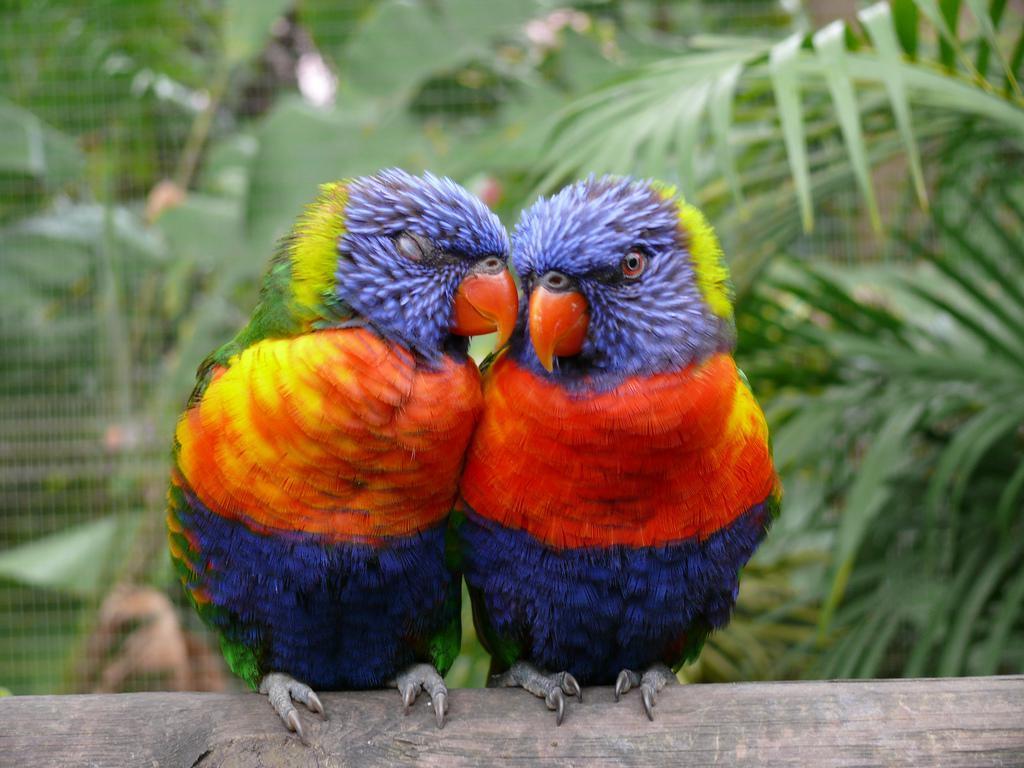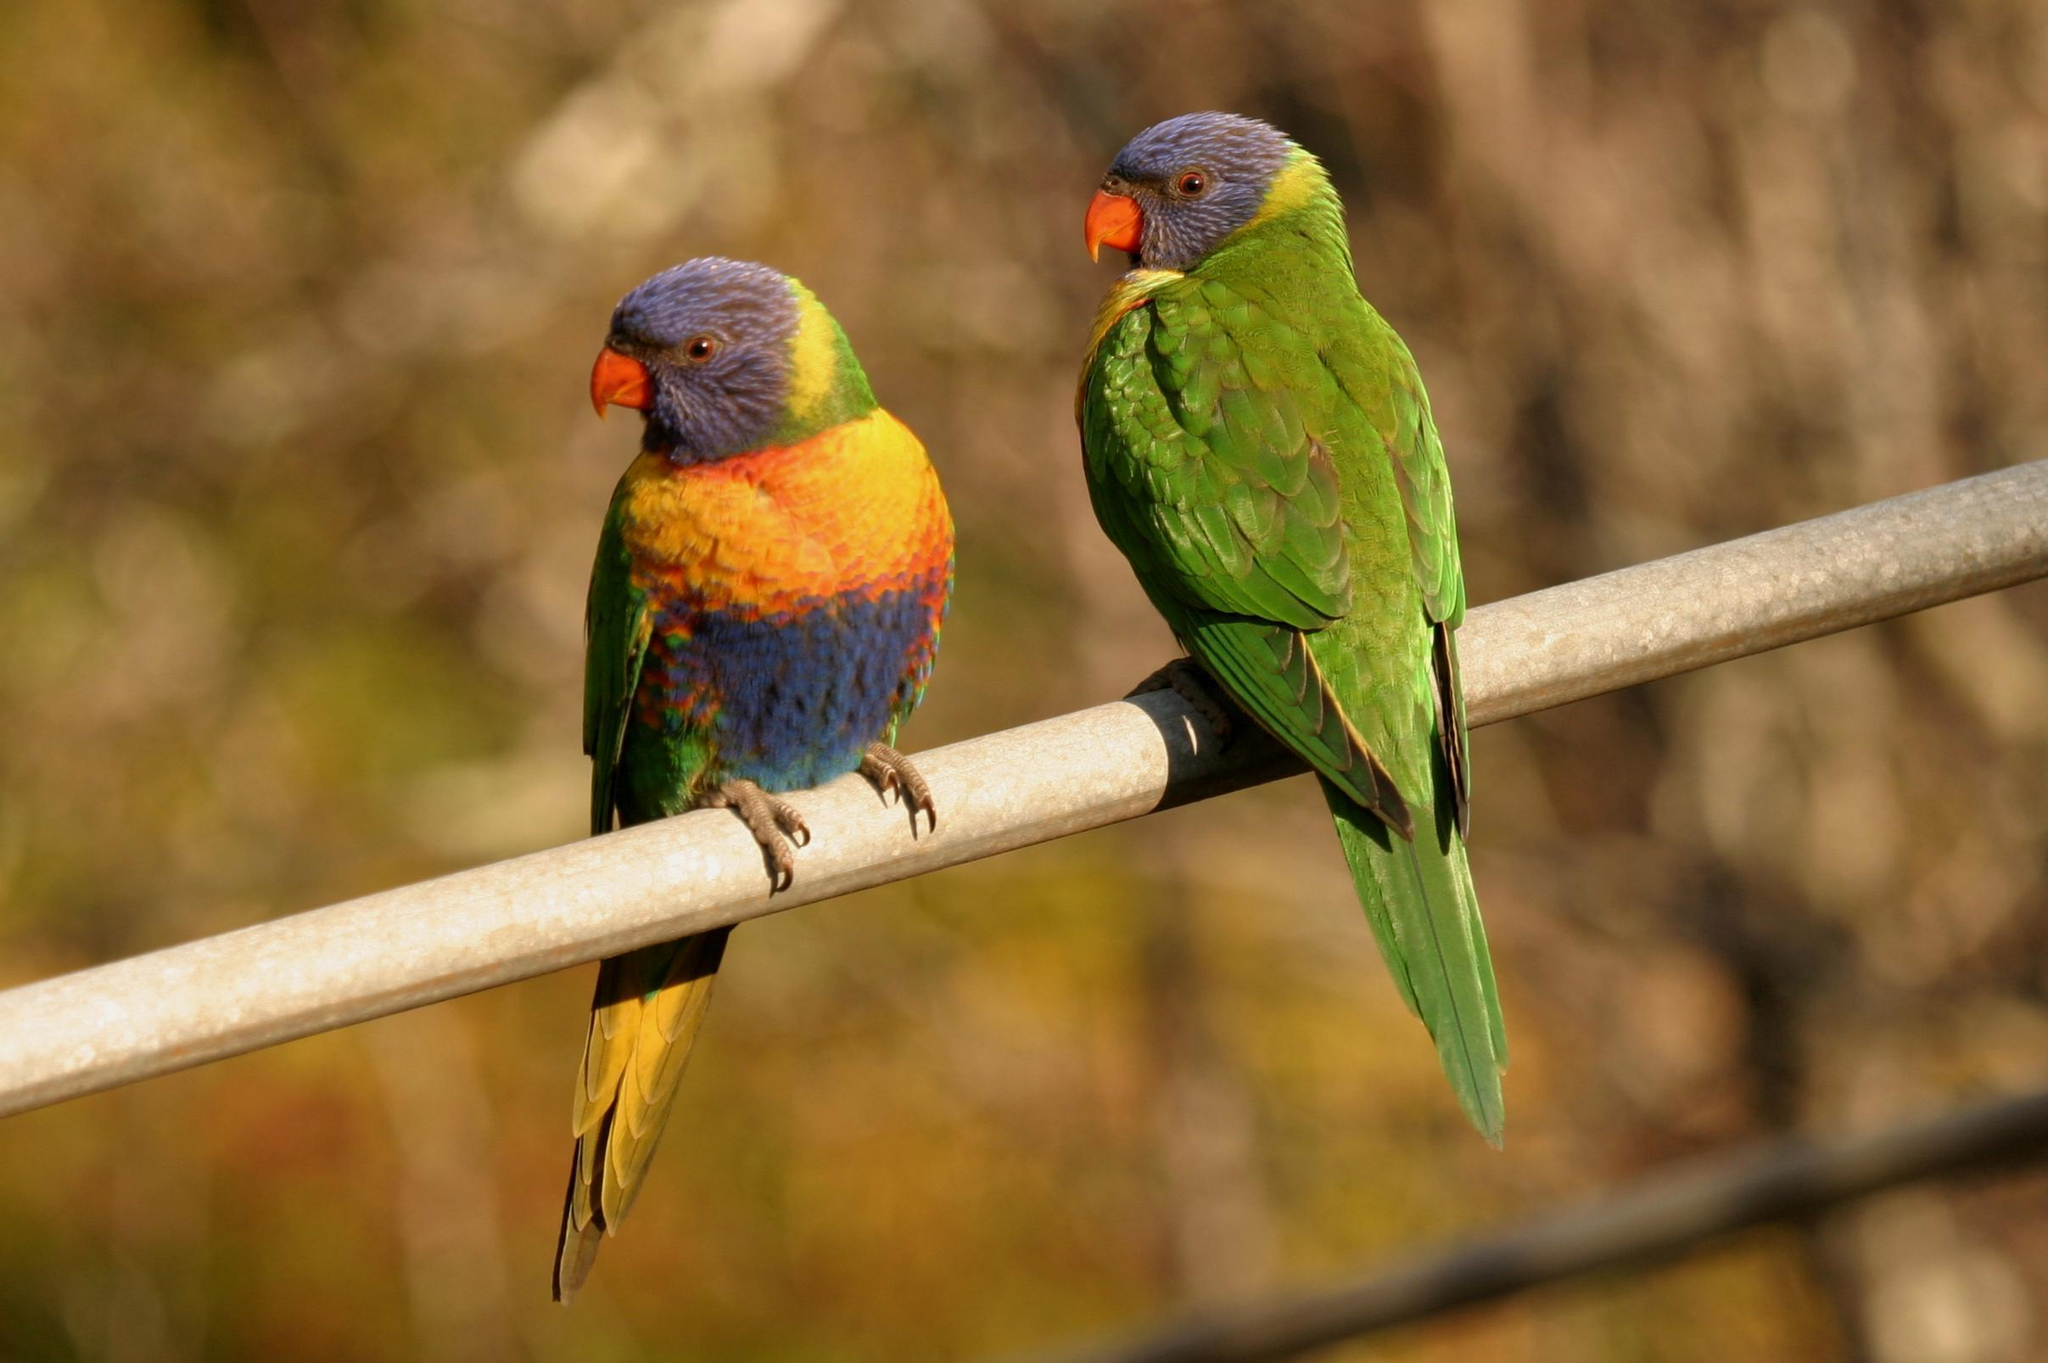The first image is the image on the left, the second image is the image on the right. For the images displayed, is the sentence "A human hand is offering food to birds in the left image." factually correct? Answer yes or no. No. 